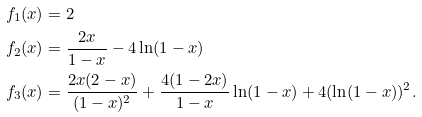<formula> <loc_0><loc_0><loc_500><loc_500>f _ { 1 } ( x ) & = 2 \\ f _ { 2 } ( x ) & = \frac { 2 x } { 1 - x } - 4 \ln ( 1 - x ) \\ f _ { 3 } ( x ) & = \frac { 2 x ( 2 - x ) } { ( 1 - x ) ^ { 2 } } + \frac { 4 ( 1 - 2 x ) } { 1 - x } \ln ( 1 - x ) + 4 ( \ln ( 1 - x ) ) ^ { 2 } .</formula> 